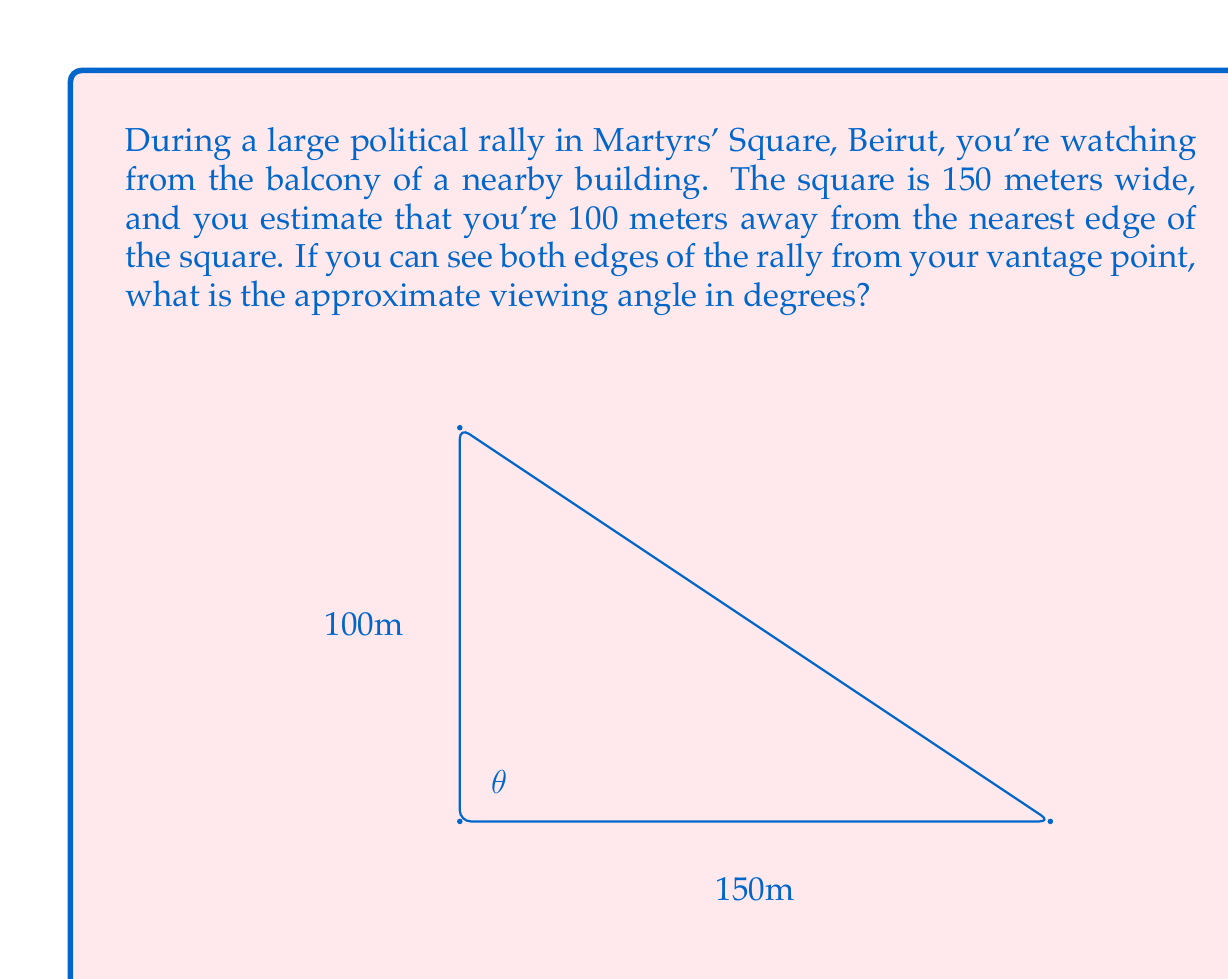What is the answer to this math problem? To solve this problem, we can use the arctangent function to find the viewing angle. Let's break it down step-by-step:

1) First, we need to identify the triangle formed by your vantage point and the edges of the square. This forms a right triangle.

2) The width of the square (150 meters) forms the base of this triangle, and your distance from the nearest edge (100 meters) forms the height.

3) We're looking for the angle θ at the top of this triangle. We can find this using the arctangent function:

   $$ θ = \tan^{-1}(\frac{\text{opposite}}{\text{adjacent}}) $$

4) In this case, the opposite side is the width of the square (150m), and the adjacent side is your distance from the square (100m).

5) Plugging these values into the formula:

   $$ θ = \tan^{-1}(\frac{150}{100}) $$

6) Simplifying:

   $$ θ = \tan^{-1}(1.5) $$

7) Using a calculator or computer to evaluate this:

   $$ θ ≈ 56.31° $$

8) Since we're asked for the full viewing angle, we need to double this value (as the calculated angle is only half of the total viewing angle):

   $$ \text{Viewing Angle} = 2θ ≈ 2 * 56.31° = 112.62° $$

Thus, the approximate viewing angle is about 112.62°.
Answer: The approximate viewing angle is 112.62°. 